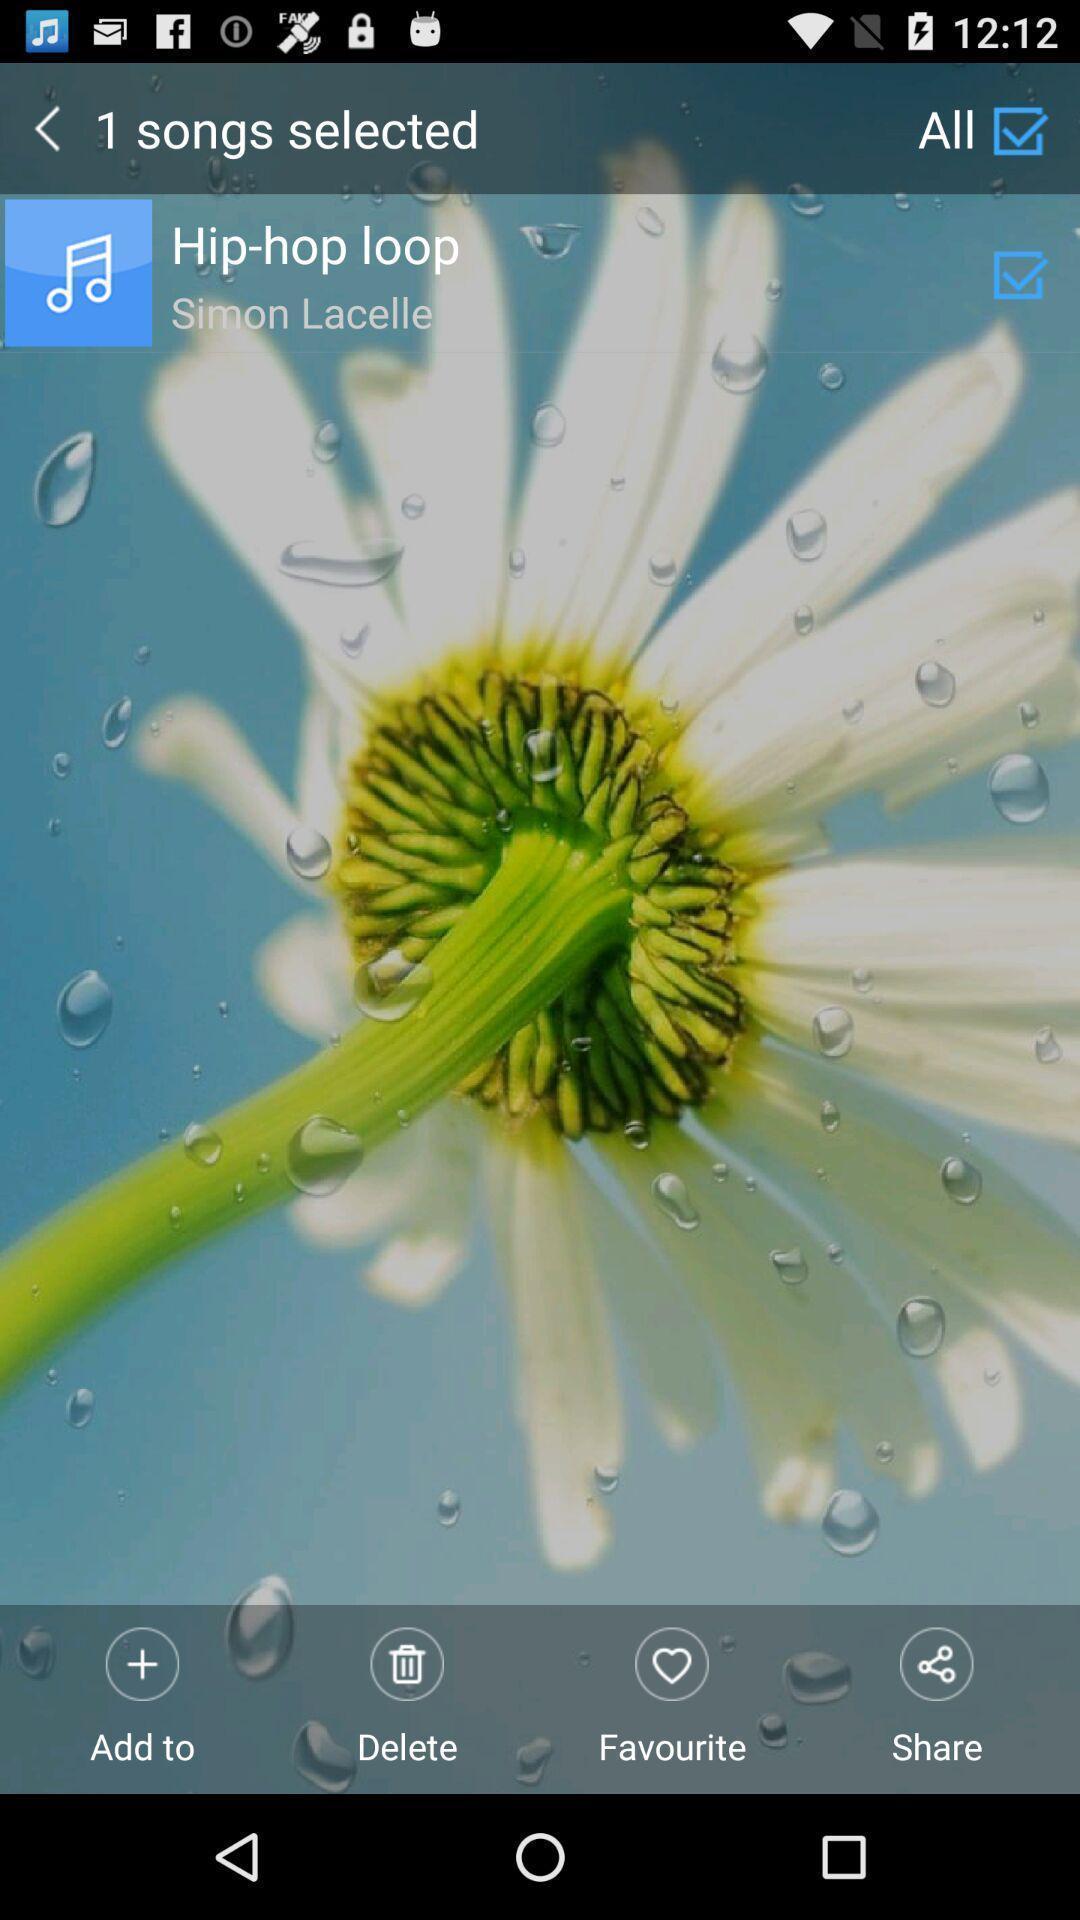Provide a description of this screenshot. Screen showing one song is selected in an music application. 